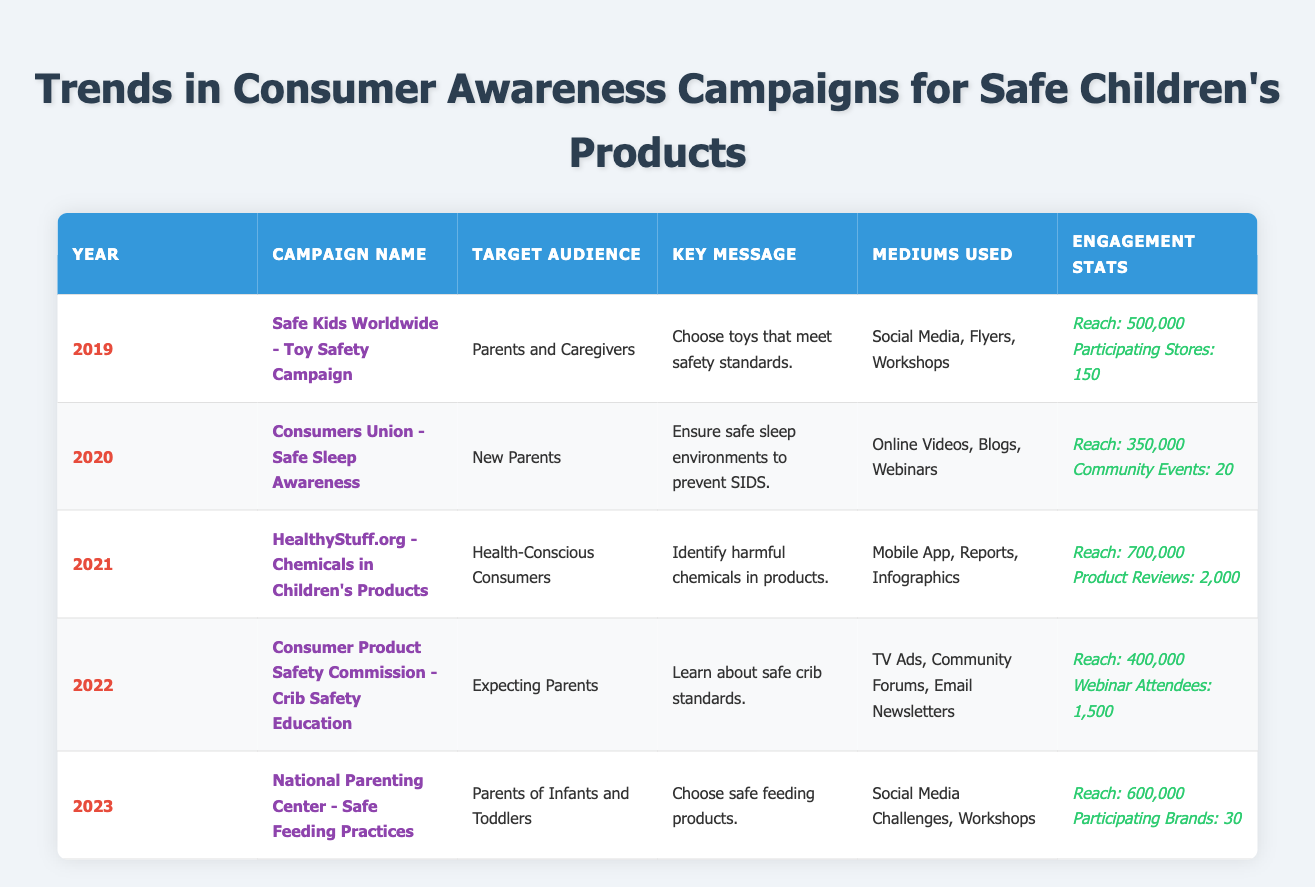What was the target audience for the campaign in 2021? The table shows that the campaign in 2021, "HealthyStuff.org - Chemicals in Children's Products," targeted "Health-Conscious Consumers." This information is found directly in the "Target Audience" column for the year 2021.
Answer: Health-Conscious Consumers Which campaign had the highest reach? By reviewing the "Engagement Stats" for each year, the campaign "HealthyStuff.org - Chemicals in Children's Products" in 2021 had the highest reach at 700,000. This is higher compared to all the other years in the table.
Answer: 700,000 How many total community events were conducted across the years in the table? The table indicates community events for 2020 (20 community events) and for 2022 (1,500 webinar attendees are not considered community events in this context). Thus, the total is only 20 since it's the only event data provided.
Answer: 20 Was there a campaign specifically targeting expecting parents? The table indicates that in 2022, there was a campaign titled "Consumer Product Safety Commission - Crib Safety Education," which specifically targeted "Expecting Parents." This confirms that such a campaign existed.
Answer: Yes Which year experienced a decline in reach compared to the previous year? By comparing the reach data: 2019 (500,000), 2020 (350,000), 2021 (700,000), 2022 (400,000), and 2023 (600,000), we see that 2020 had a decline from 2019 (500,000 to 350,000) and 2022 had a decline from 2021 (700,000 to 400,000). Thus, the years 2020 and 2022 experienced declines.
Answer: 2020 and 2022 